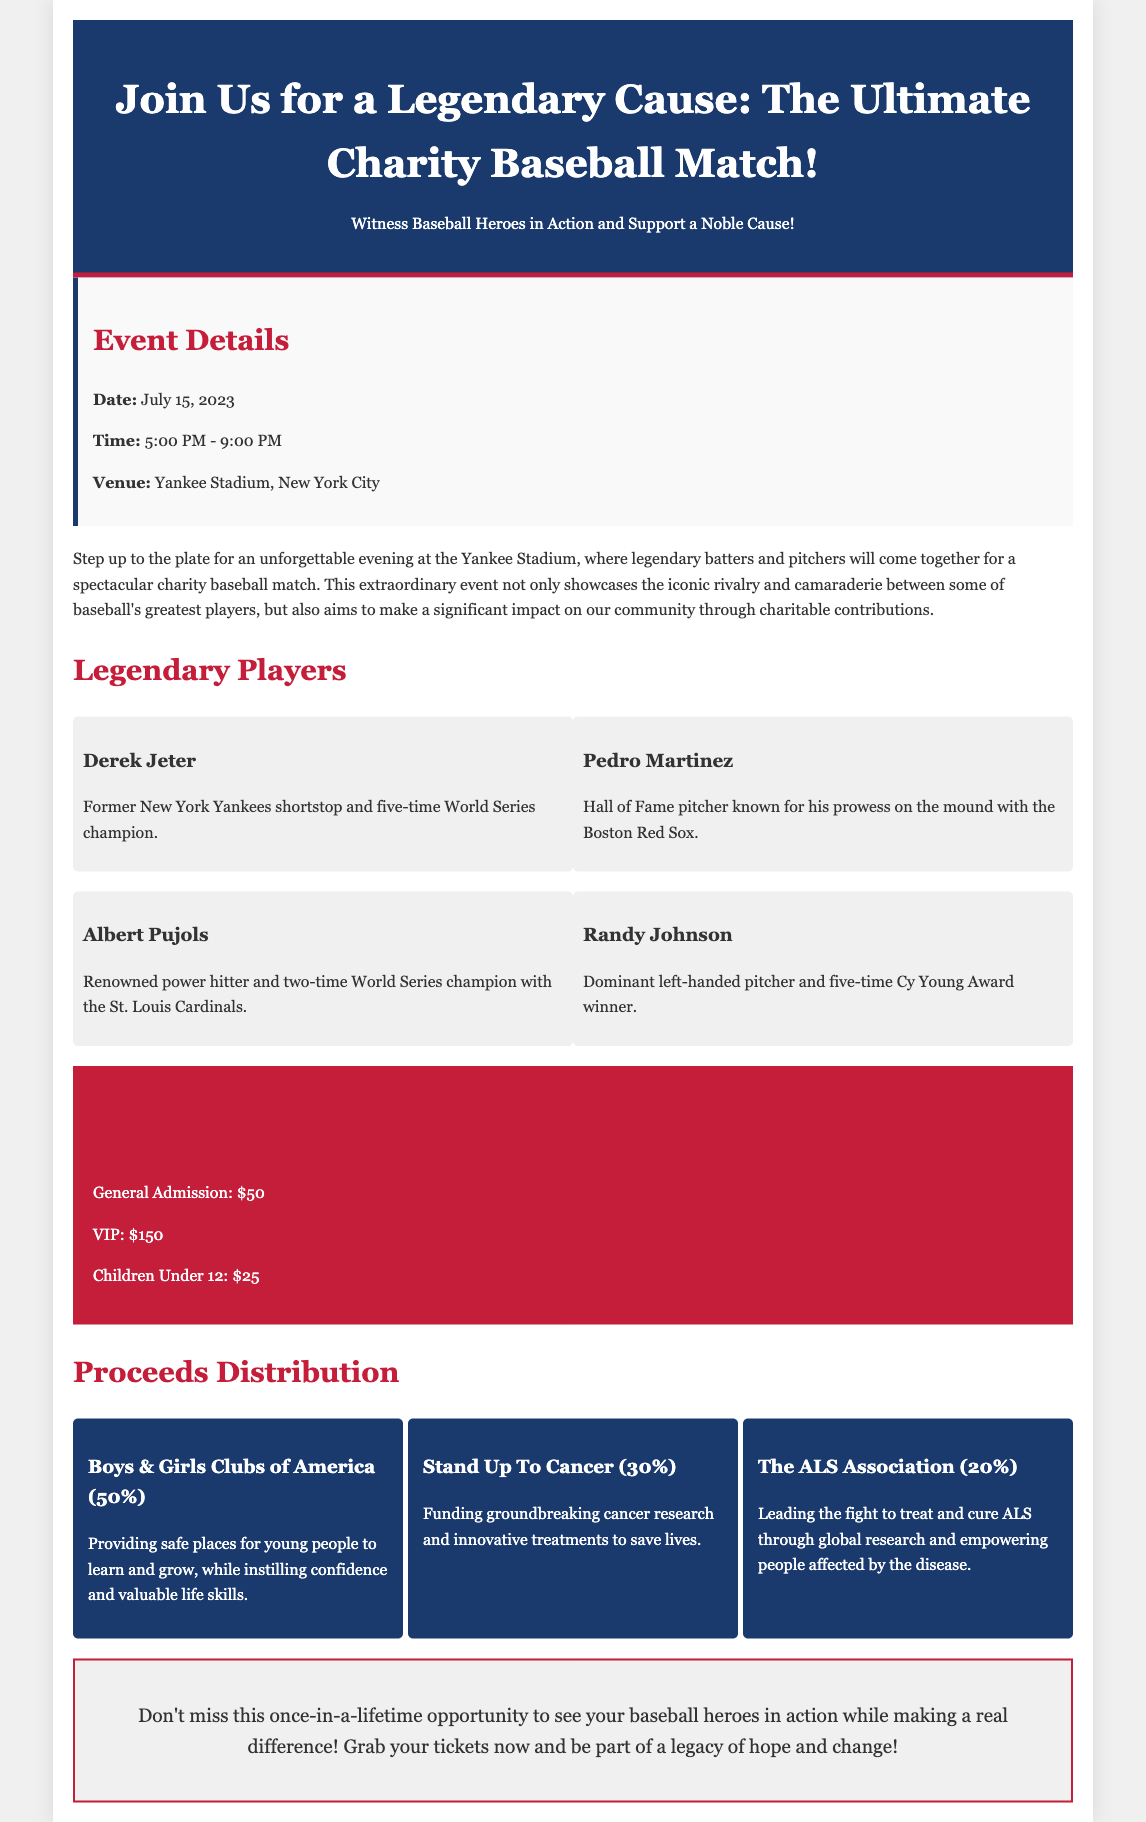What is the date of the charity match? The date is specified in the event details section of the document.
Answer: July 15, 2023 What is the venue for the match? The venue is mentioned alongside the date and time in the event details section.
Answer: Yankee Stadium How much is a VIP ticket? Ticket prices are listed in the ticket section of the document.
Answer: $150 Who receives the largest percentage of proceeds? Proceeds distribution details provide the percentages allocated to each charity, with Boys & Girls Clubs of America receiving the most.
Answer: 50% Name one of the legendary players participating in the match. The document lists several players as part of the event.
Answer: Derek Jeter How long is the charity baseball match scheduled to last? The time duration can be calculated from the start and end times provided in the event details.
Answer: 4 hours What percentage of proceeds goes to Stand Up To Cancer? The document clearly states the percentage allocation for each charity.
Answer: 30% What type of event is being promoted in this document? The overall description and title indicate the nature of the event.
Answer: Charity Baseball Match 